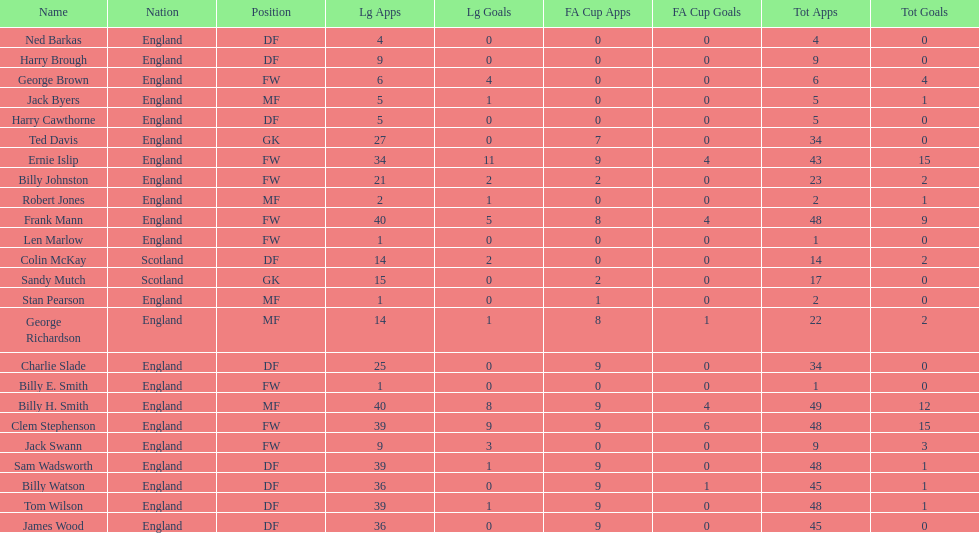Name the nation with the most appearances. England. 